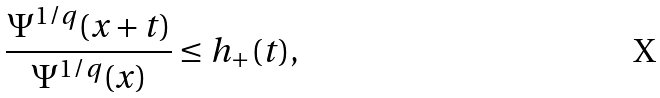Convert formula to latex. <formula><loc_0><loc_0><loc_500><loc_500>\frac { \Psi ^ { 1 / q } ( x + t ) } { \Psi ^ { 1 / q } ( x ) } \leq h _ { + } ( t ) ,</formula> 